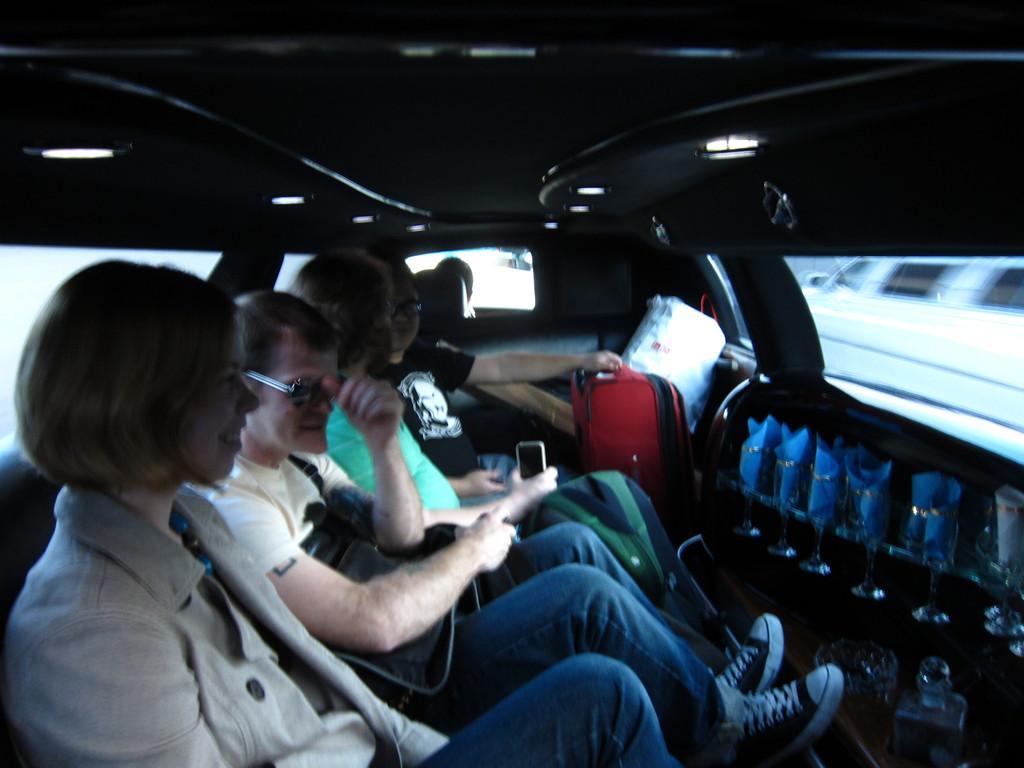Could you give a brief overview of what you see in this image? In the image in the center we can see one vehicle. In the vehicle,we can see few people were sitting and they were holding some objects. And they were smiling,which we can see on their faces. And we can see few other objects. 